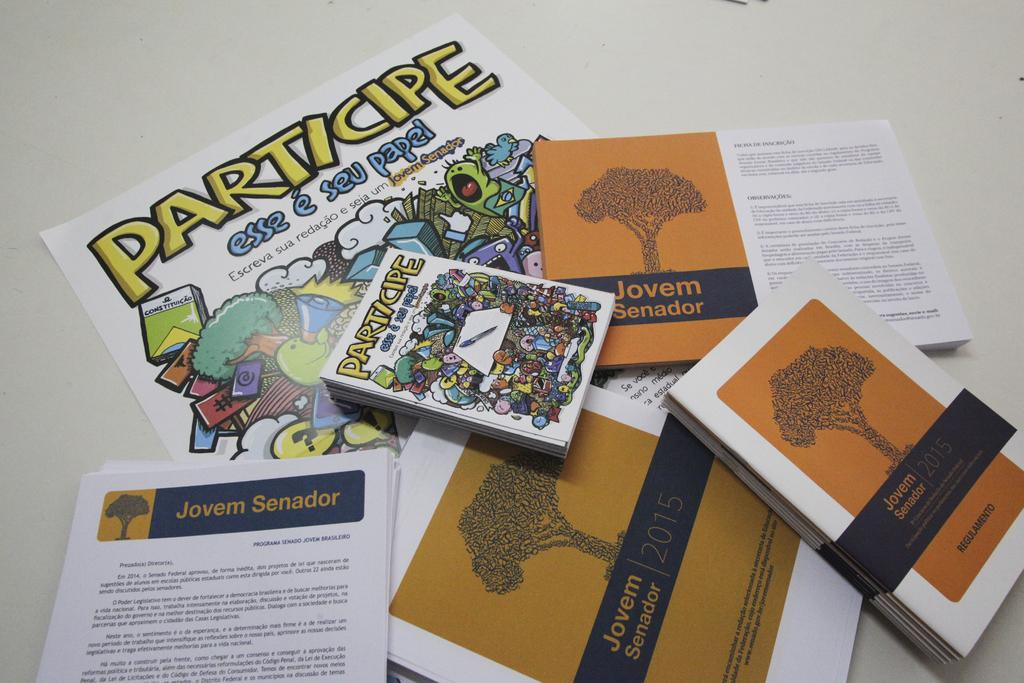<image>
Create a compact narrative representing the image presented. Several blue and orange papers and books promote Jovem Senador. 